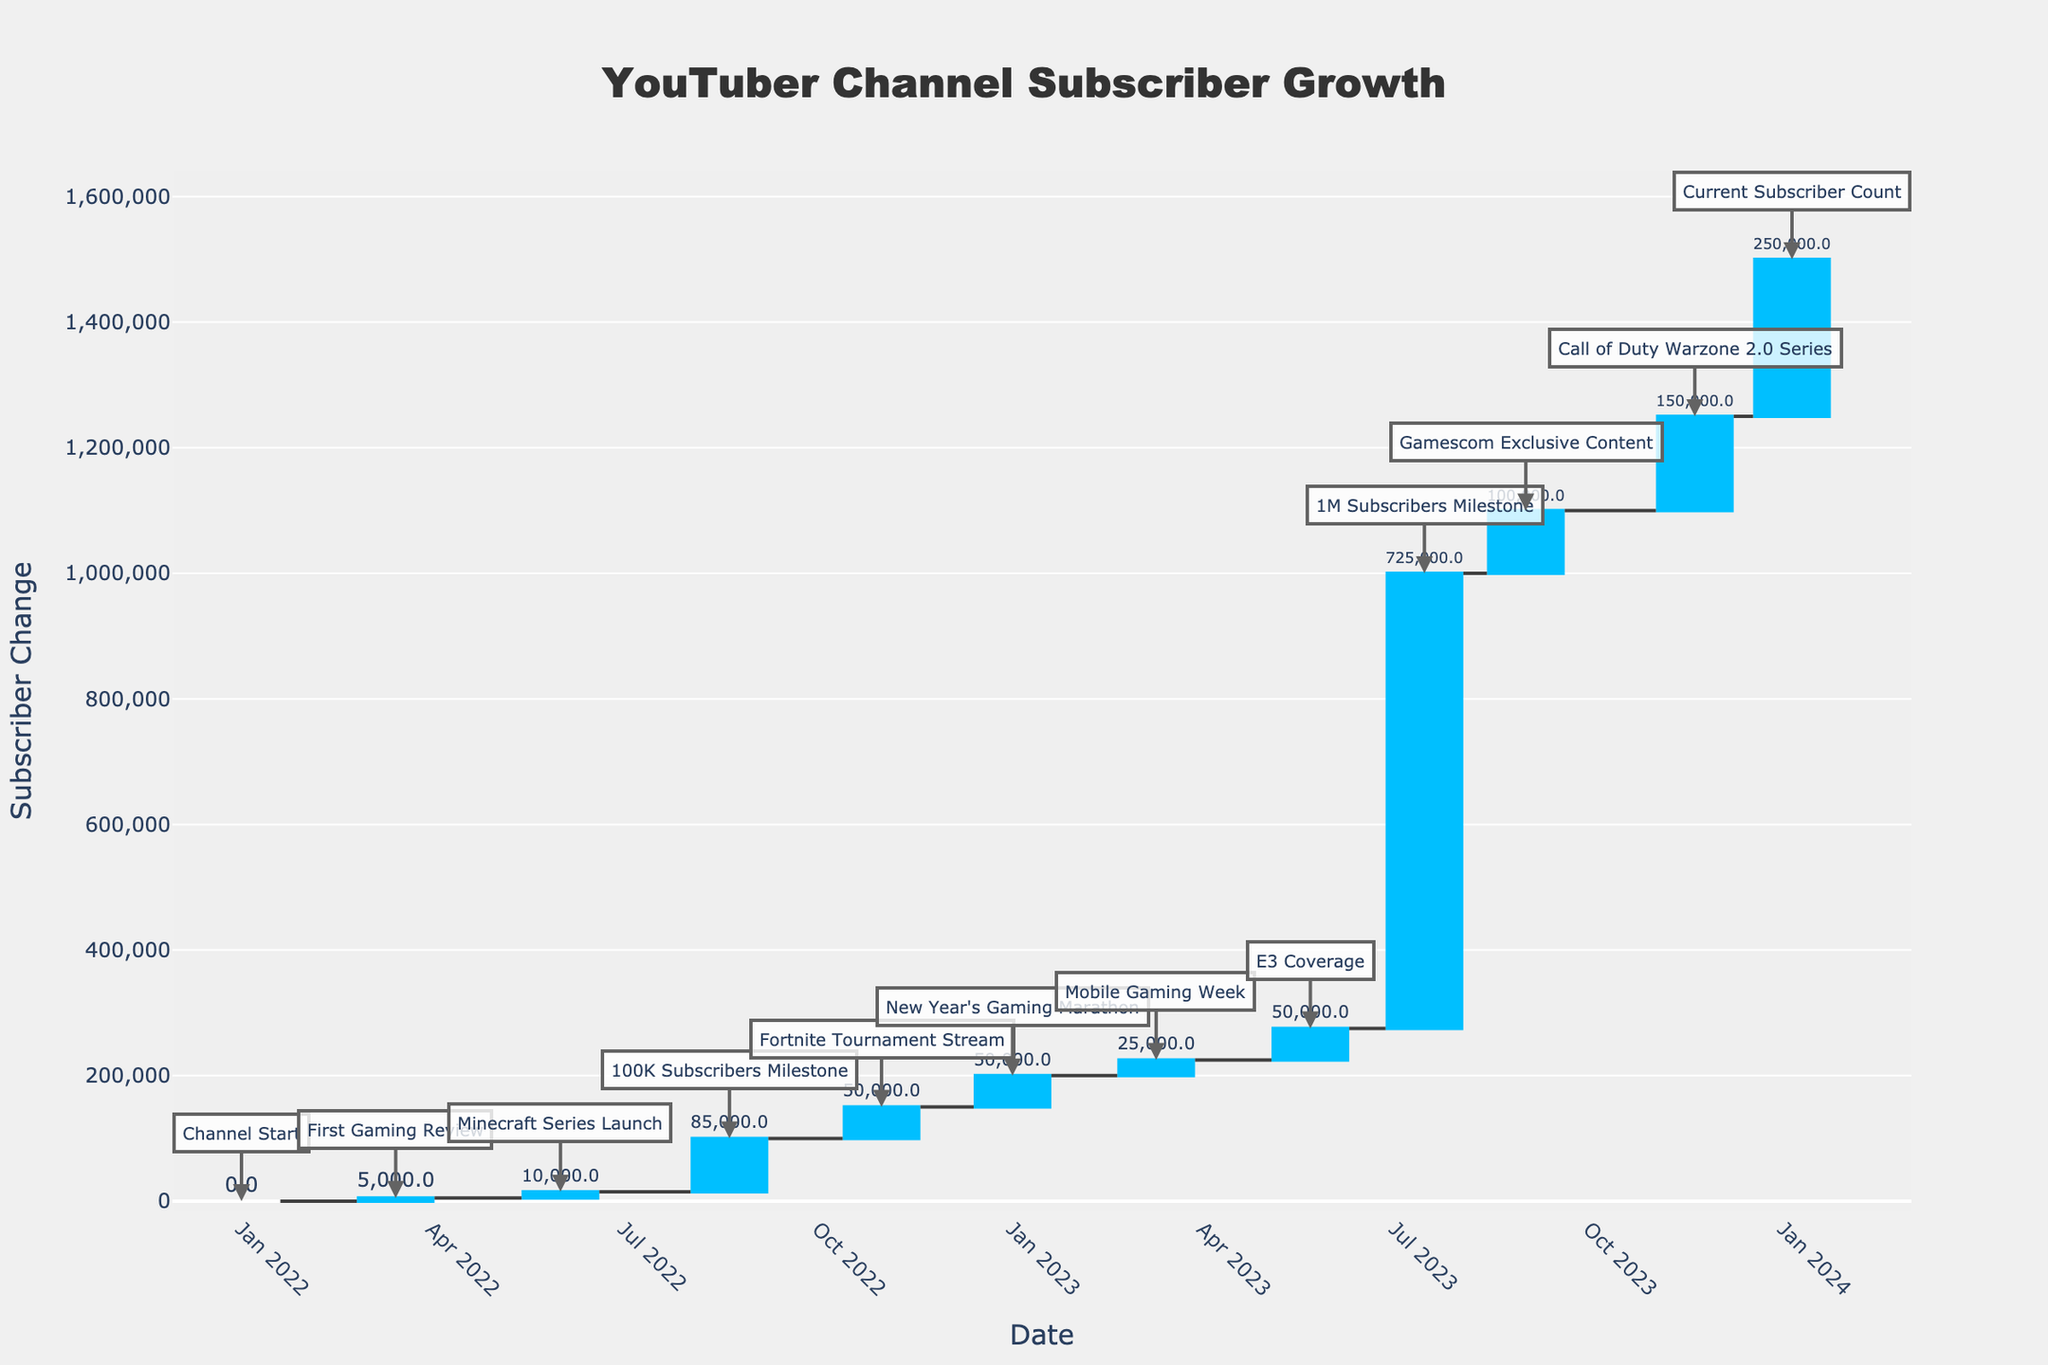What's the title of the chart? The title is typically found at the top of the chart. In this case, it reads "YouTuber Channel Subscriber Growth".
Answer: YouTuber Channel Subscriber Growth What is the change in subscribers during the "New Year's Gaming Marathon"? The hover text provides details on each event's subscriber change. According to the hover text for this event, the change is 50,000 subscribers.
Answer: 50,000 How many subscribers were there after the "E3 Coverage"? Look at the annotations for specific events. The annotation for "E3 Coverage" shows that the total number of subscribers was 275,000 after this event.
Answer: 275,000 Which event had the largest increase in subscribers? Compare the 'Change' values in the hover text. The "1M Subscribers Milestone" had the largest increase, with a change of 725,000 subscribers.
Answer: 1M Subscribers Milestone What is the difference in the number of subscribers between the "100K Subscribers Milestone" and "Gamescom Exclusive Content"? To find the difference, subtract the number of subscribers after "Gamescom Exclusive Content" from that after "100K Subscribers Milestone". This is 1,100,000 - 100,000 = 1,000,000 subscribers.
Answer: 1,000,000 How many events are annotated on the chart? Count the individual annotations on the chart for each specific event. There are 12 events annotated.
Answer: 12 Which event occurred after the "Mobile Gaming Week"? The next event in sequence after "Mobile Gaming Week", according to the dates and annotations, is "E3 Coverage" on May 22, 2023.
Answer: E3 Coverage What was the subscriber count at the start of the channel? The annotation for "Channel Start" shows that the starting subscriber count was 0.
Answer: 0 Did any events cause a decrease in subscribers? Waterfall charts show decreasing values with a different color (e.g., pink). No such colors are observed in this chart, indicating no events caused a decrease.
Answer: No Which event contributed to reaching 1,500,000 subscribers? The "Current Subscriber Count" annotation shows 1,500,000 subscribers, which was achieved after the event "Call of Duty Warzone 2.0 Series".
Answer: Call of Duty Warzone 2.0 Series 